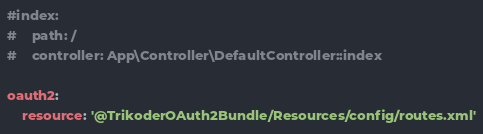<code> <loc_0><loc_0><loc_500><loc_500><_YAML_>#index:
#    path: /
#    controller: App\Controller\DefaultController::index

oauth2:
    resource: '@TrikoderOAuth2Bundle/Resources/config/routes.xml'
</code> 